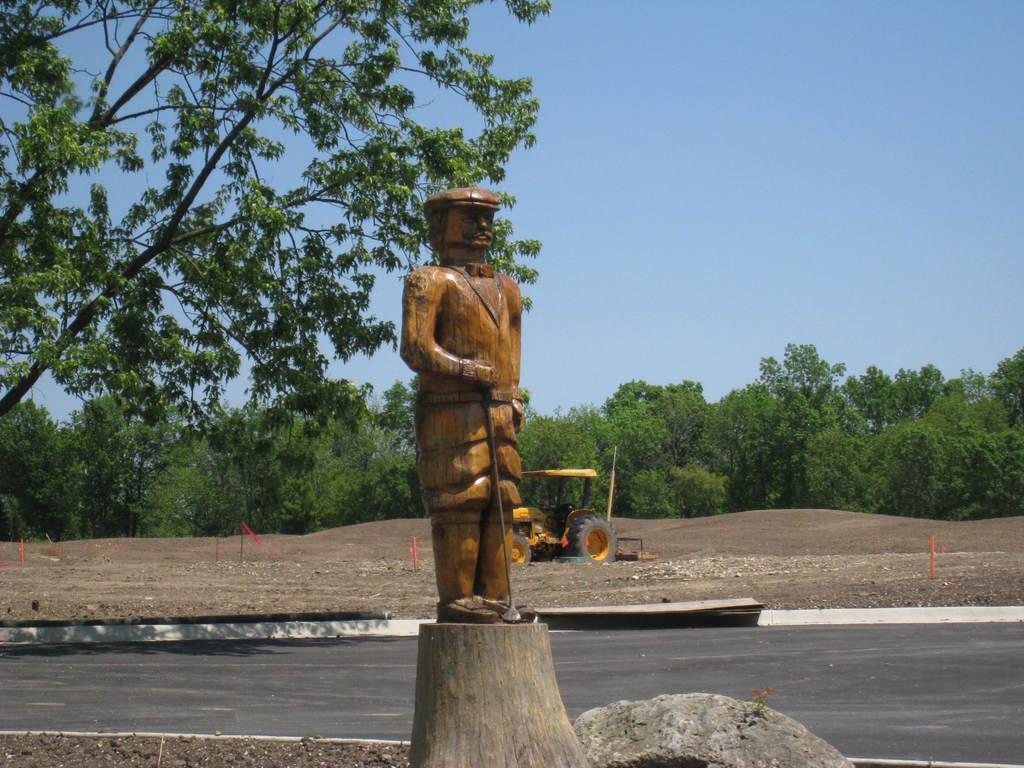In one or two sentences, can you explain what this image depicts? In the center of the image we can see a statue. In the background there is a vehicle, trees and sky. At the bottom there is a road. 